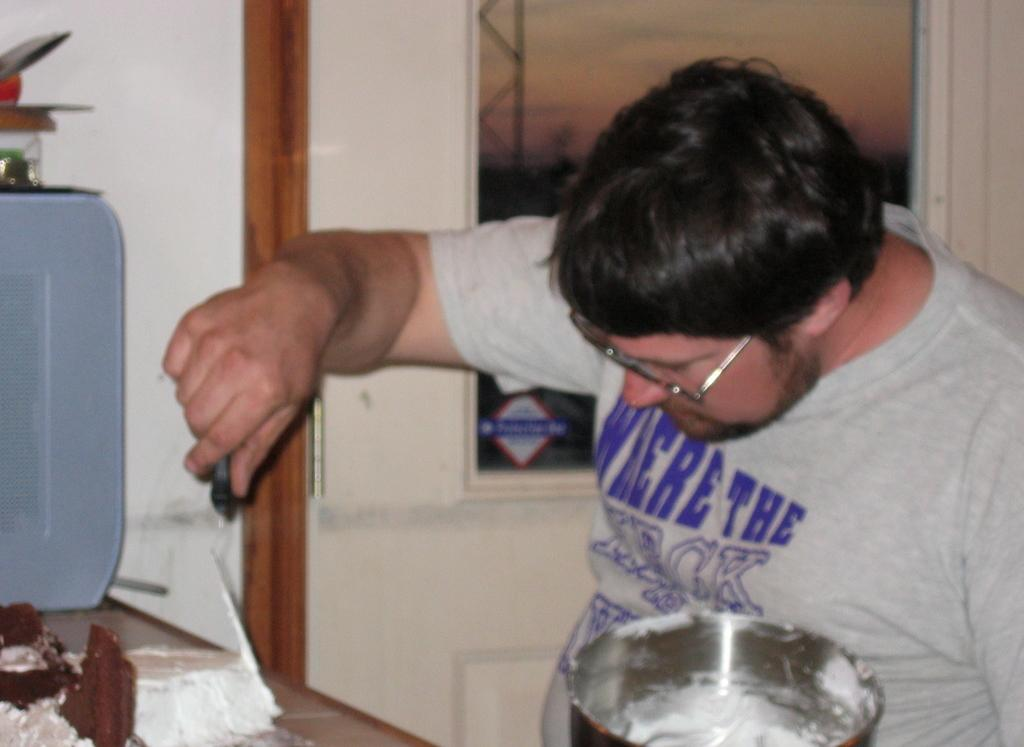<image>
Give a short and clear explanation of the subsequent image. Man wearing glasses and the shirt there says Where the heck. 